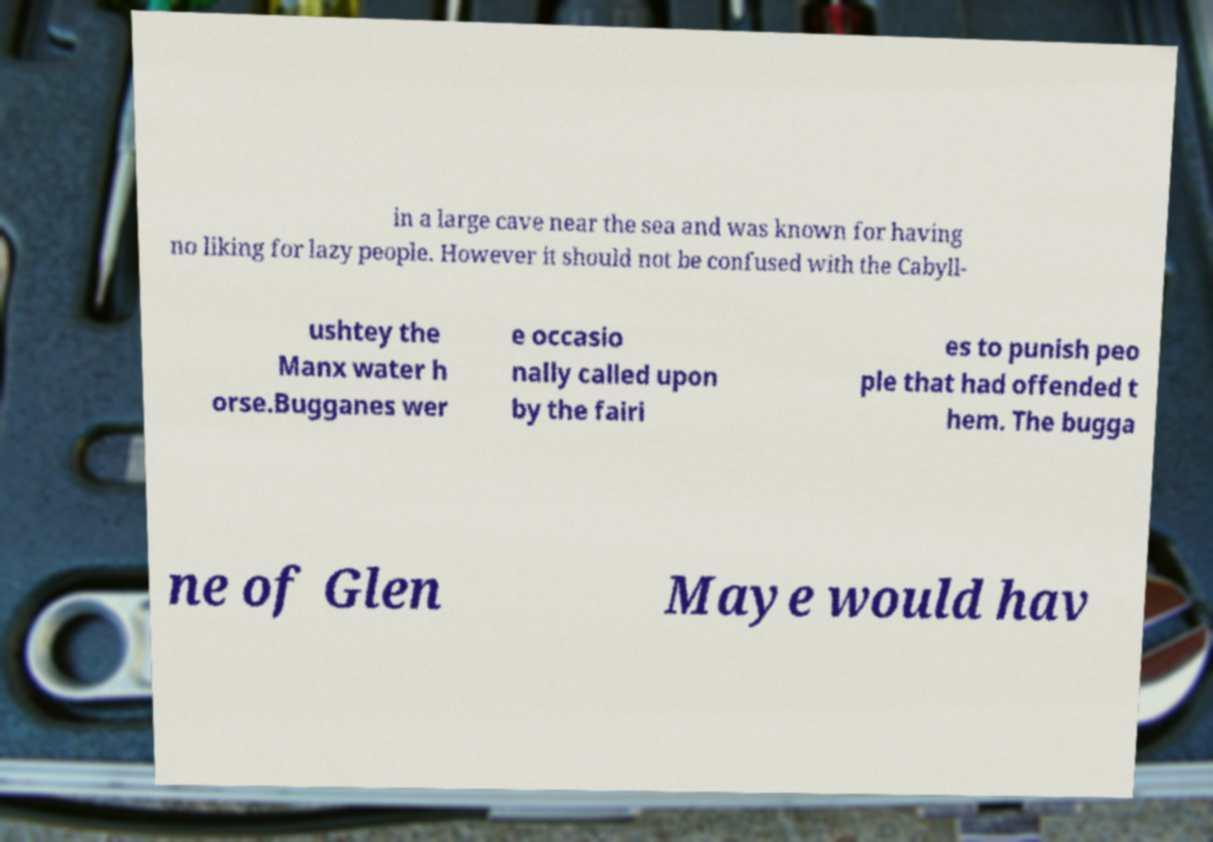What messages or text are displayed in this image? I need them in a readable, typed format. in a large cave near the sea and was known for having no liking for lazy people. However it should not be confused with the Cabyll- ushtey the Manx water h orse.Bugganes wer e occasio nally called upon by the fairi es to punish peo ple that had offended t hem. The bugga ne of Glen Maye would hav 